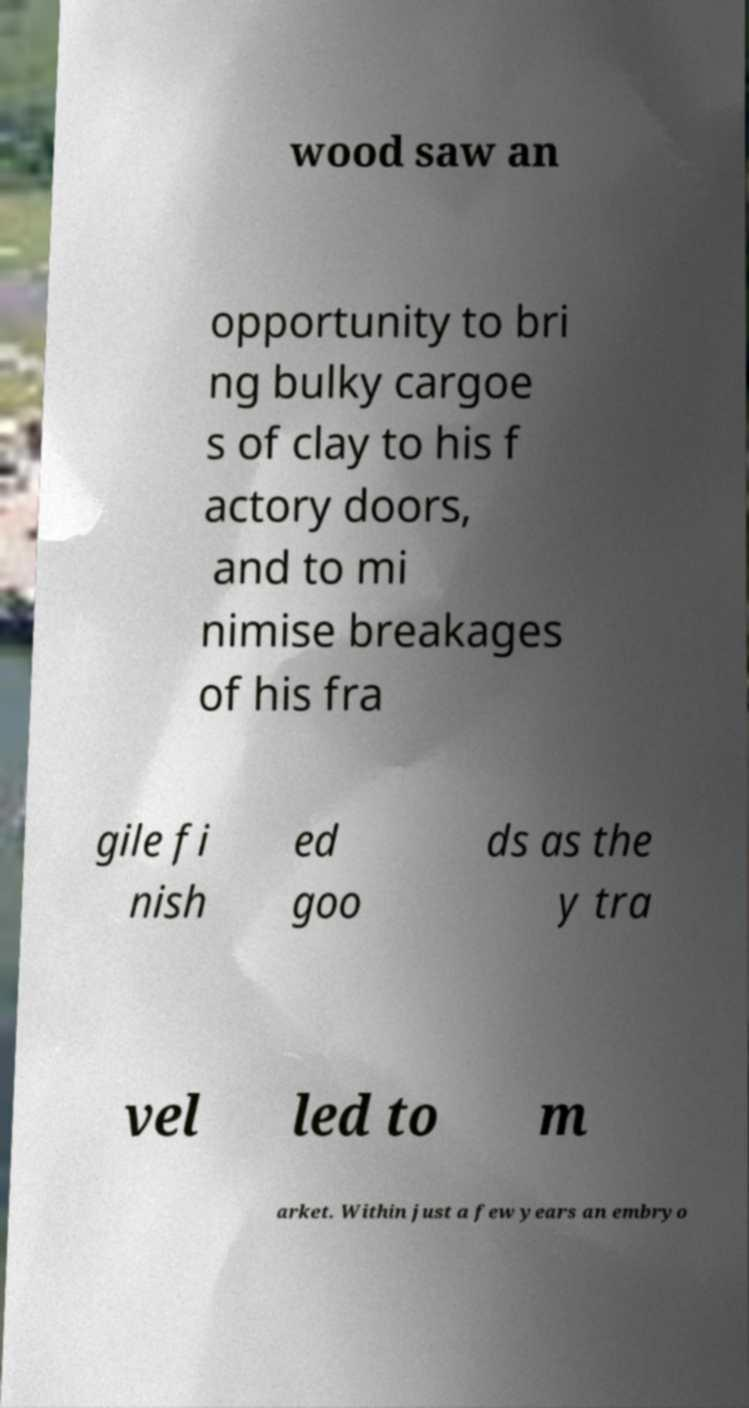Please read and relay the text visible in this image. What does it say? wood saw an opportunity to bri ng bulky cargoe s of clay to his f actory doors, and to mi nimise breakages of his fra gile fi nish ed goo ds as the y tra vel led to m arket. Within just a few years an embryo 